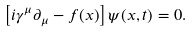<formula> <loc_0><loc_0><loc_500><loc_500>\left [ i \gamma ^ { \mu } \partial _ { \mu } - f ( x ) \right ] \psi ( x , t ) = 0 .</formula> 